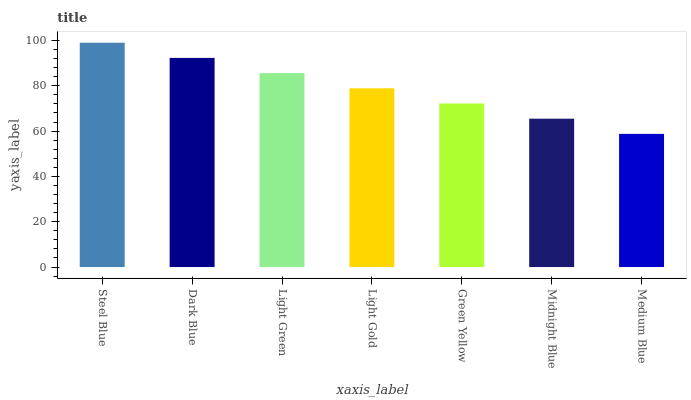Is Medium Blue the minimum?
Answer yes or no. Yes. Is Steel Blue the maximum?
Answer yes or no. Yes. Is Dark Blue the minimum?
Answer yes or no. No. Is Dark Blue the maximum?
Answer yes or no. No. Is Steel Blue greater than Dark Blue?
Answer yes or no. Yes. Is Dark Blue less than Steel Blue?
Answer yes or no. Yes. Is Dark Blue greater than Steel Blue?
Answer yes or no. No. Is Steel Blue less than Dark Blue?
Answer yes or no. No. Is Light Gold the high median?
Answer yes or no. Yes. Is Light Gold the low median?
Answer yes or no. Yes. Is Green Yellow the high median?
Answer yes or no. No. Is Medium Blue the low median?
Answer yes or no. No. 